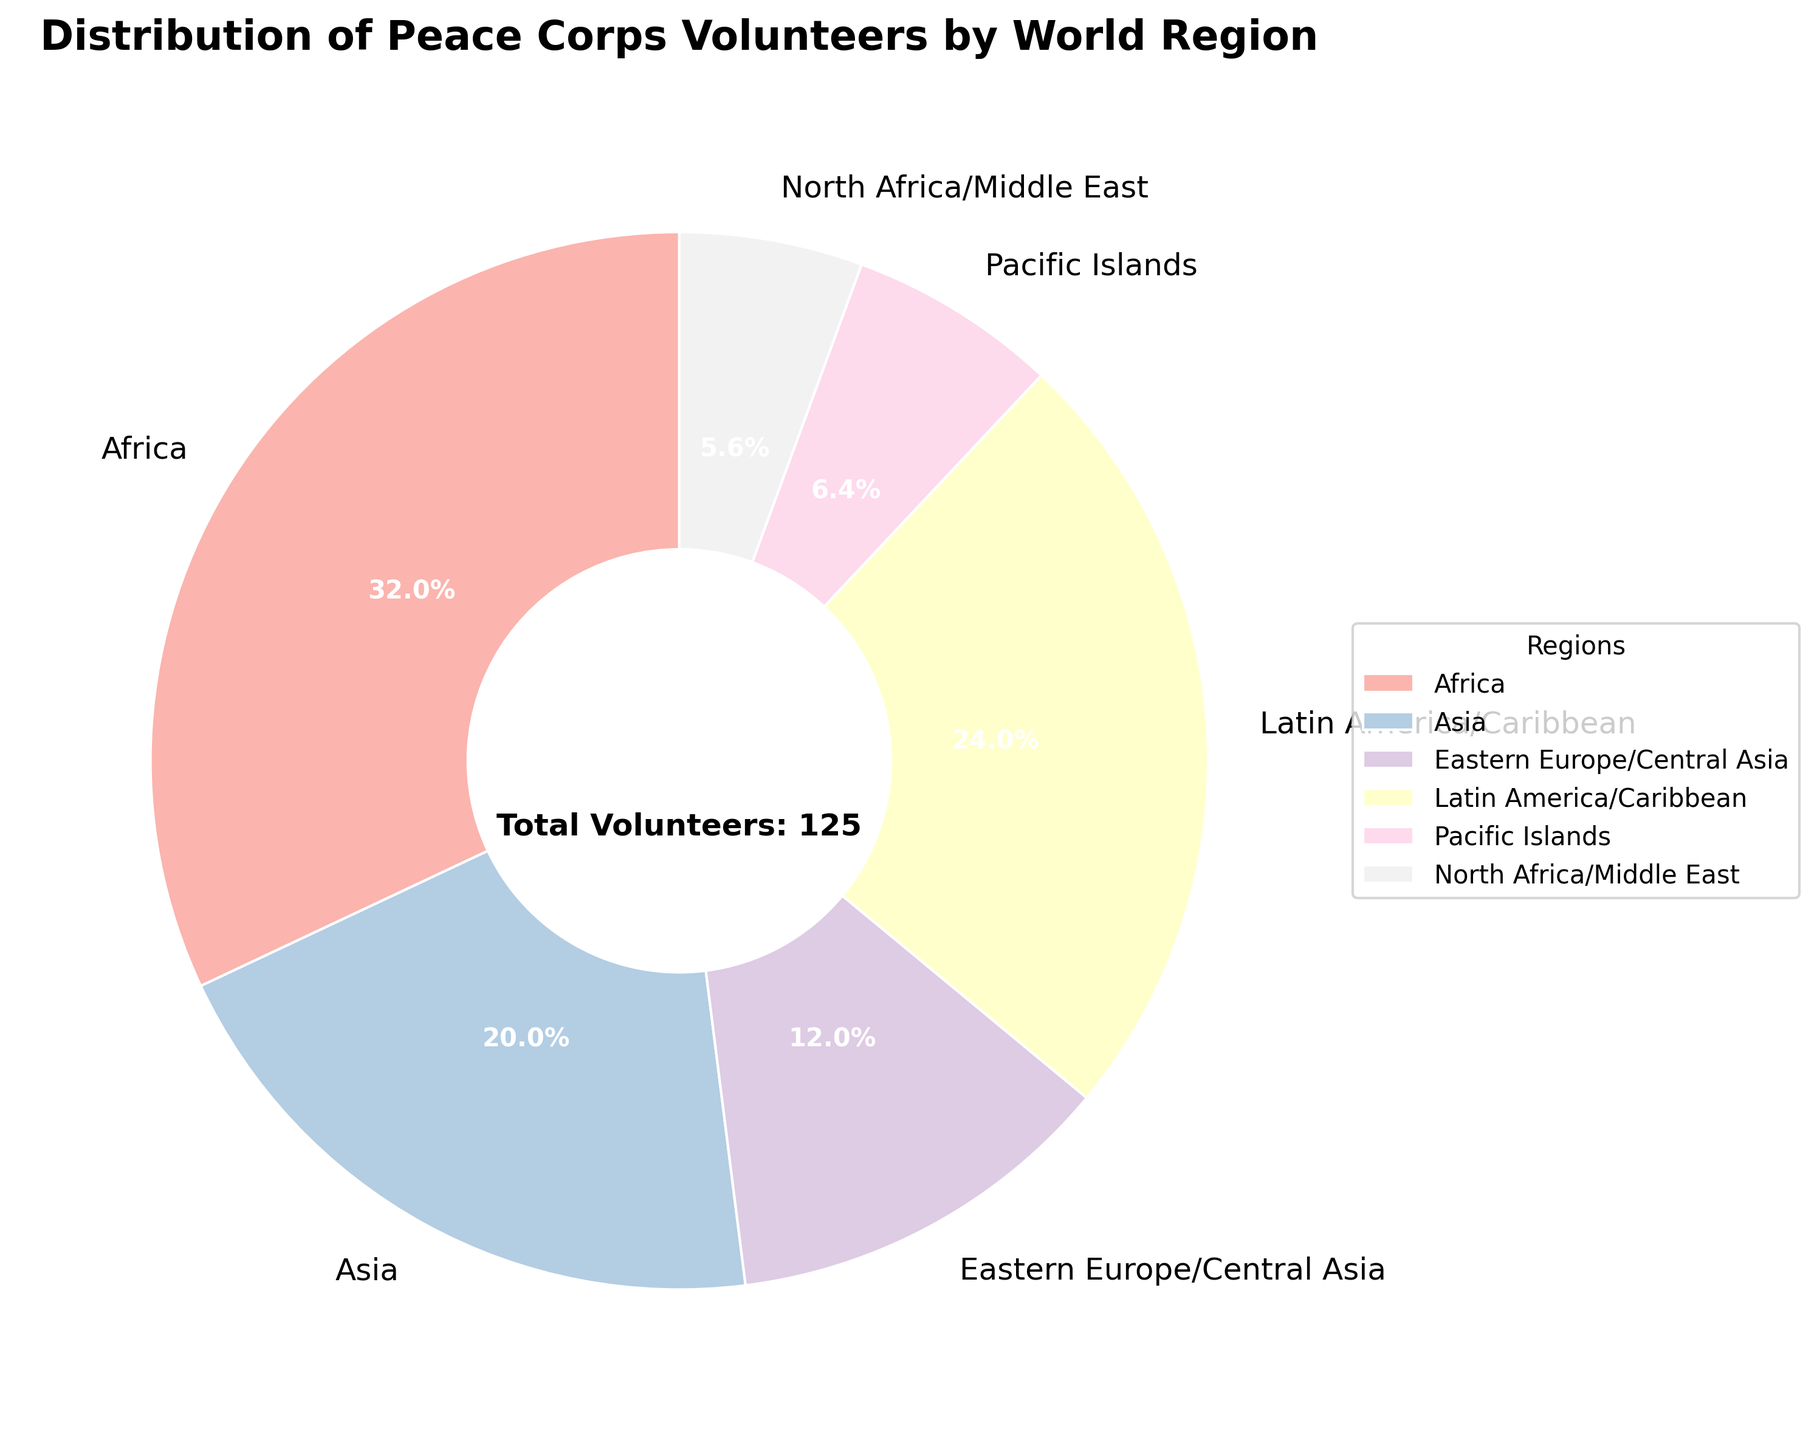Which region has the highest number of volunteers? Look at the size of the slices in the pie chart, Africa has the largest slice.
Answer: Africa Which region has fewer volunteers, Pacific Islands or North Africa/Middle East? Compare the sizes of the two slices; the slice for North Africa/Middle East is smaller than the one for Pacific Islands.
Answer: North Africa/Middle East How many more volunteers are in Latin America/Caribbean than in Eastern Europe/Central Asia? Latin America/Caribbean has 30 volunteers and Eastern Europe/Central Asia has 15. The difference is 30 - 15 = 15.
Answer: 15 What percentage of the volunteers are in Asia? Referring to the figure, Asia's slice is labeled as 25%.
Answer: 25% Do Africa and Latin America/Caribbean together make up more than half of the total volunteers? Sum Africa and Latin America/Caribbean volunteers: 40 + 30 = 70. There are 125 total volunteers, so 70 is more than half (62.5).
Answer: Yes Which region has the second fewest volunteers? North Africa/Middle East has the fewest, and Pacific Islands has the second fewest visible.
Answer: Pacific Islands What is the difference in percentage points between the region with the most volunteers and the region with the fewest? Africa has 40/125*100 = 32% and North Africa/Middle East has 7/125*100 ≈ 5.6%. The difference is 32 - 5.6 ≈ 26.4 percentage points.
Answer: 26.4% What is the total number of volunteers in the three regions with fewest volunteers? Sum the volunteers in North Africa/Middle East, Pacific Islands, and Eastern Europe/Central Asia: 7 + 8 + 15 = 30.
Answer: 30 Which region occupies the smallest slice visually? Comparing visually, the smallest slice corresponds to North Africa/Middle East.
Answer: North Africa/Middle East What is the combined percentage of volunteers in the regions of Asia and Eastern Europe/Central Asia? Sum the volunteers: 25 + 15 = 40. Calculate the percentage: (40/125)*100 = 32%.
Answer: 32% 